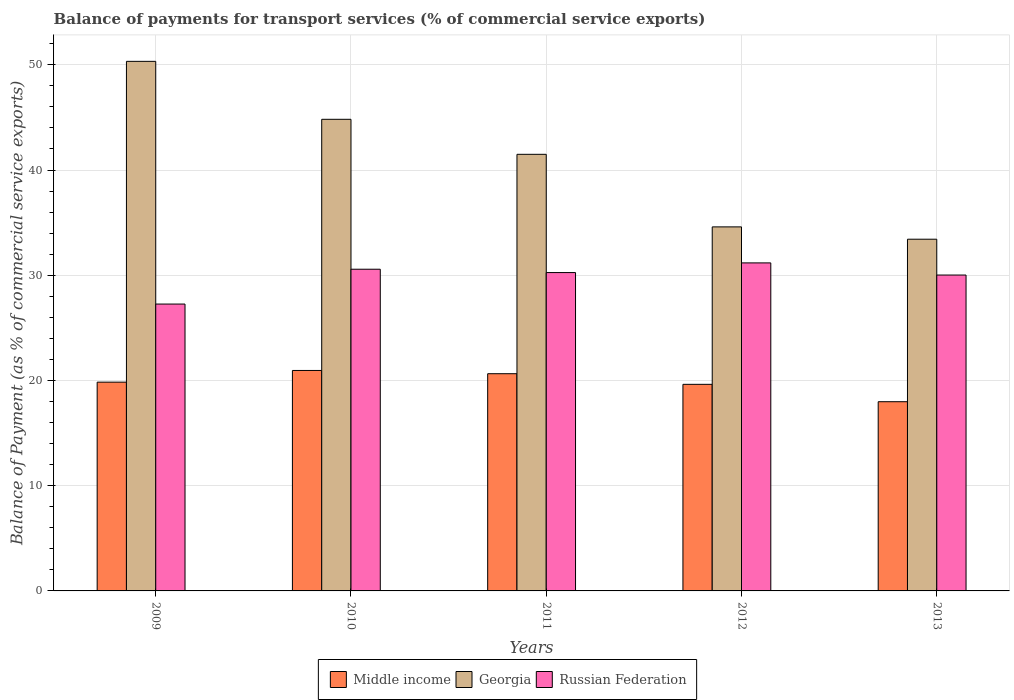How many different coloured bars are there?
Provide a short and direct response. 3. Are the number of bars per tick equal to the number of legend labels?
Ensure brevity in your answer.  Yes. Are the number of bars on each tick of the X-axis equal?
Your answer should be very brief. Yes. How many bars are there on the 1st tick from the left?
Your response must be concise. 3. How many bars are there on the 1st tick from the right?
Keep it short and to the point. 3. What is the balance of payments for transport services in Russian Federation in 2011?
Keep it short and to the point. 30.25. Across all years, what is the maximum balance of payments for transport services in Middle income?
Your response must be concise. 20.95. Across all years, what is the minimum balance of payments for transport services in Georgia?
Your response must be concise. 33.42. What is the total balance of payments for transport services in Russian Federation in the graph?
Keep it short and to the point. 149.28. What is the difference between the balance of payments for transport services in Georgia in 2009 and that in 2010?
Provide a succinct answer. 5.51. What is the difference between the balance of payments for transport services in Georgia in 2011 and the balance of payments for transport services in Russian Federation in 2009?
Ensure brevity in your answer.  14.23. What is the average balance of payments for transport services in Middle income per year?
Offer a very short reply. 19.81. In the year 2013, what is the difference between the balance of payments for transport services in Middle income and balance of payments for transport services in Georgia?
Offer a terse response. -15.44. In how many years, is the balance of payments for transport services in Georgia greater than 26 %?
Offer a very short reply. 5. What is the ratio of the balance of payments for transport services in Russian Federation in 2010 to that in 2013?
Provide a short and direct response. 1.02. Is the balance of payments for transport services in Georgia in 2009 less than that in 2010?
Give a very brief answer. No. Is the difference between the balance of payments for transport services in Middle income in 2011 and 2013 greater than the difference between the balance of payments for transport services in Georgia in 2011 and 2013?
Your answer should be very brief. No. What is the difference between the highest and the second highest balance of payments for transport services in Georgia?
Your answer should be very brief. 5.51. What is the difference between the highest and the lowest balance of payments for transport services in Georgia?
Offer a very short reply. 16.9. What does the 3rd bar from the left in 2011 represents?
Your response must be concise. Russian Federation. What does the 1st bar from the right in 2012 represents?
Make the answer very short. Russian Federation. Are all the bars in the graph horizontal?
Offer a terse response. No. How many years are there in the graph?
Ensure brevity in your answer.  5. Does the graph contain any zero values?
Give a very brief answer. No. Does the graph contain grids?
Give a very brief answer. Yes. Where does the legend appear in the graph?
Provide a short and direct response. Bottom center. How are the legend labels stacked?
Your response must be concise. Horizontal. What is the title of the graph?
Offer a very short reply. Balance of payments for transport services (% of commercial service exports). Does "Somalia" appear as one of the legend labels in the graph?
Your answer should be compact. No. What is the label or title of the X-axis?
Your answer should be compact. Years. What is the label or title of the Y-axis?
Offer a terse response. Balance of Payment (as % of commercial service exports). What is the Balance of Payment (as % of commercial service exports) of Middle income in 2009?
Your answer should be compact. 19.84. What is the Balance of Payment (as % of commercial service exports) of Georgia in 2009?
Offer a very short reply. 50.33. What is the Balance of Payment (as % of commercial service exports) of Russian Federation in 2009?
Offer a terse response. 27.26. What is the Balance of Payment (as % of commercial service exports) in Middle income in 2010?
Keep it short and to the point. 20.95. What is the Balance of Payment (as % of commercial service exports) of Georgia in 2010?
Make the answer very short. 44.82. What is the Balance of Payment (as % of commercial service exports) of Russian Federation in 2010?
Offer a very short reply. 30.57. What is the Balance of Payment (as % of commercial service exports) in Middle income in 2011?
Keep it short and to the point. 20.64. What is the Balance of Payment (as % of commercial service exports) of Georgia in 2011?
Your answer should be compact. 41.49. What is the Balance of Payment (as % of commercial service exports) of Russian Federation in 2011?
Ensure brevity in your answer.  30.25. What is the Balance of Payment (as % of commercial service exports) of Middle income in 2012?
Give a very brief answer. 19.63. What is the Balance of Payment (as % of commercial service exports) in Georgia in 2012?
Keep it short and to the point. 34.6. What is the Balance of Payment (as % of commercial service exports) of Russian Federation in 2012?
Your response must be concise. 31.17. What is the Balance of Payment (as % of commercial service exports) in Middle income in 2013?
Provide a short and direct response. 17.98. What is the Balance of Payment (as % of commercial service exports) in Georgia in 2013?
Make the answer very short. 33.42. What is the Balance of Payment (as % of commercial service exports) in Russian Federation in 2013?
Your answer should be very brief. 30.02. Across all years, what is the maximum Balance of Payment (as % of commercial service exports) of Middle income?
Your response must be concise. 20.95. Across all years, what is the maximum Balance of Payment (as % of commercial service exports) of Georgia?
Provide a succinct answer. 50.33. Across all years, what is the maximum Balance of Payment (as % of commercial service exports) in Russian Federation?
Keep it short and to the point. 31.17. Across all years, what is the minimum Balance of Payment (as % of commercial service exports) in Middle income?
Keep it short and to the point. 17.98. Across all years, what is the minimum Balance of Payment (as % of commercial service exports) in Georgia?
Provide a short and direct response. 33.42. Across all years, what is the minimum Balance of Payment (as % of commercial service exports) of Russian Federation?
Your answer should be compact. 27.26. What is the total Balance of Payment (as % of commercial service exports) of Middle income in the graph?
Ensure brevity in your answer.  99.05. What is the total Balance of Payment (as % of commercial service exports) in Georgia in the graph?
Your answer should be very brief. 204.66. What is the total Balance of Payment (as % of commercial service exports) in Russian Federation in the graph?
Ensure brevity in your answer.  149.28. What is the difference between the Balance of Payment (as % of commercial service exports) of Middle income in 2009 and that in 2010?
Provide a short and direct response. -1.11. What is the difference between the Balance of Payment (as % of commercial service exports) in Georgia in 2009 and that in 2010?
Keep it short and to the point. 5.51. What is the difference between the Balance of Payment (as % of commercial service exports) of Russian Federation in 2009 and that in 2010?
Ensure brevity in your answer.  -3.31. What is the difference between the Balance of Payment (as % of commercial service exports) of Middle income in 2009 and that in 2011?
Offer a terse response. -0.8. What is the difference between the Balance of Payment (as % of commercial service exports) of Georgia in 2009 and that in 2011?
Your answer should be compact. 8.84. What is the difference between the Balance of Payment (as % of commercial service exports) in Russian Federation in 2009 and that in 2011?
Offer a very short reply. -2.99. What is the difference between the Balance of Payment (as % of commercial service exports) in Middle income in 2009 and that in 2012?
Provide a short and direct response. 0.21. What is the difference between the Balance of Payment (as % of commercial service exports) of Georgia in 2009 and that in 2012?
Provide a succinct answer. 15.73. What is the difference between the Balance of Payment (as % of commercial service exports) of Russian Federation in 2009 and that in 2012?
Make the answer very short. -3.91. What is the difference between the Balance of Payment (as % of commercial service exports) in Middle income in 2009 and that in 2013?
Your response must be concise. 1.86. What is the difference between the Balance of Payment (as % of commercial service exports) in Georgia in 2009 and that in 2013?
Your answer should be compact. 16.9. What is the difference between the Balance of Payment (as % of commercial service exports) in Russian Federation in 2009 and that in 2013?
Your answer should be compact. -2.76. What is the difference between the Balance of Payment (as % of commercial service exports) in Middle income in 2010 and that in 2011?
Give a very brief answer. 0.31. What is the difference between the Balance of Payment (as % of commercial service exports) in Georgia in 2010 and that in 2011?
Your answer should be compact. 3.33. What is the difference between the Balance of Payment (as % of commercial service exports) of Russian Federation in 2010 and that in 2011?
Make the answer very short. 0.32. What is the difference between the Balance of Payment (as % of commercial service exports) in Middle income in 2010 and that in 2012?
Make the answer very short. 1.32. What is the difference between the Balance of Payment (as % of commercial service exports) in Georgia in 2010 and that in 2012?
Give a very brief answer. 10.22. What is the difference between the Balance of Payment (as % of commercial service exports) in Russian Federation in 2010 and that in 2012?
Your response must be concise. -0.6. What is the difference between the Balance of Payment (as % of commercial service exports) in Middle income in 2010 and that in 2013?
Offer a very short reply. 2.97. What is the difference between the Balance of Payment (as % of commercial service exports) of Georgia in 2010 and that in 2013?
Ensure brevity in your answer.  11.4. What is the difference between the Balance of Payment (as % of commercial service exports) in Russian Federation in 2010 and that in 2013?
Provide a short and direct response. 0.55. What is the difference between the Balance of Payment (as % of commercial service exports) of Middle income in 2011 and that in 2012?
Offer a terse response. 1.01. What is the difference between the Balance of Payment (as % of commercial service exports) in Georgia in 2011 and that in 2012?
Make the answer very short. 6.9. What is the difference between the Balance of Payment (as % of commercial service exports) of Russian Federation in 2011 and that in 2012?
Your response must be concise. -0.92. What is the difference between the Balance of Payment (as % of commercial service exports) in Middle income in 2011 and that in 2013?
Offer a terse response. 2.66. What is the difference between the Balance of Payment (as % of commercial service exports) in Georgia in 2011 and that in 2013?
Your response must be concise. 8.07. What is the difference between the Balance of Payment (as % of commercial service exports) in Russian Federation in 2011 and that in 2013?
Make the answer very short. 0.24. What is the difference between the Balance of Payment (as % of commercial service exports) in Middle income in 2012 and that in 2013?
Offer a very short reply. 1.65. What is the difference between the Balance of Payment (as % of commercial service exports) of Georgia in 2012 and that in 2013?
Provide a succinct answer. 1.17. What is the difference between the Balance of Payment (as % of commercial service exports) of Russian Federation in 2012 and that in 2013?
Keep it short and to the point. 1.15. What is the difference between the Balance of Payment (as % of commercial service exports) in Middle income in 2009 and the Balance of Payment (as % of commercial service exports) in Georgia in 2010?
Your response must be concise. -24.98. What is the difference between the Balance of Payment (as % of commercial service exports) in Middle income in 2009 and the Balance of Payment (as % of commercial service exports) in Russian Federation in 2010?
Ensure brevity in your answer.  -10.73. What is the difference between the Balance of Payment (as % of commercial service exports) of Georgia in 2009 and the Balance of Payment (as % of commercial service exports) of Russian Federation in 2010?
Keep it short and to the point. 19.75. What is the difference between the Balance of Payment (as % of commercial service exports) in Middle income in 2009 and the Balance of Payment (as % of commercial service exports) in Georgia in 2011?
Give a very brief answer. -21.65. What is the difference between the Balance of Payment (as % of commercial service exports) of Middle income in 2009 and the Balance of Payment (as % of commercial service exports) of Russian Federation in 2011?
Ensure brevity in your answer.  -10.41. What is the difference between the Balance of Payment (as % of commercial service exports) of Georgia in 2009 and the Balance of Payment (as % of commercial service exports) of Russian Federation in 2011?
Provide a succinct answer. 20.07. What is the difference between the Balance of Payment (as % of commercial service exports) of Middle income in 2009 and the Balance of Payment (as % of commercial service exports) of Georgia in 2012?
Ensure brevity in your answer.  -14.75. What is the difference between the Balance of Payment (as % of commercial service exports) of Middle income in 2009 and the Balance of Payment (as % of commercial service exports) of Russian Federation in 2012?
Offer a very short reply. -11.33. What is the difference between the Balance of Payment (as % of commercial service exports) in Georgia in 2009 and the Balance of Payment (as % of commercial service exports) in Russian Federation in 2012?
Your response must be concise. 19.15. What is the difference between the Balance of Payment (as % of commercial service exports) in Middle income in 2009 and the Balance of Payment (as % of commercial service exports) in Georgia in 2013?
Offer a very short reply. -13.58. What is the difference between the Balance of Payment (as % of commercial service exports) of Middle income in 2009 and the Balance of Payment (as % of commercial service exports) of Russian Federation in 2013?
Offer a terse response. -10.18. What is the difference between the Balance of Payment (as % of commercial service exports) in Georgia in 2009 and the Balance of Payment (as % of commercial service exports) in Russian Federation in 2013?
Offer a very short reply. 20.31. What is the difference between the Balance of Payment (as % of commercial service exports) in Middle income in 2010 and the Balance of Payment (as % of commercial service exports) in Georgia in 2011?
Your answer should be compact. -20.54. What is the difference between the Balance of Payment (as % of commercial service exports) in Middle income in 2010 and the Balance of Payment (as % of commercial service exports) in Russian Federation in 2011?
Your answer should be compact. -9.3. What is the difference between the Balance of Payment (as % of commercial service exports) in Georgia in 2010 and the Balance of Payment (as % of commercial service exports) in Russian Federation in 2011?
Keep it short and to the point. 14.57. What is the difference between the Balance of Payment (as % of commercial service exports) in Middle income in 2010 and the Balance of Payment (as % of commercial service exports) in Georgia in 2012?
Keep it short and to the point. -13.64. What is the difference between the Balance of Payment (as % of commercial service exports) in Middle income in 2010 and the Balance of Payment (as % of commercial service exports) in Russian Federation in 2012?
Your answer should be very brief. -10.22. What is the difference between the Balance of Payment (as % of commercial service exports) of Georgia in 2010 and the Balance of Payment (as % of commercial service exports) of Russian Federation in 2012?
Provide a succinct answer. 13.65. What is the difference between the Balance of Payment (as % of commercial service exports) of Middle income in 2010 and the Balance of Payment (as % of commercial service exports) of Georgia in 2013?
Provide a succinct answer. -12.47. What is the difference between the Balance of Payment (as % of commercial service exports) in Middle income in 2010 and the Balance of Payment (as % of commercial service exports) in Russian Federation in 2013?
Your answer should be compact. -9.07. What is the difference between the Balance of Payment (as % of commercial service exports) of Georgia in 2010 and the Balance of Payment (as % of commercial service exports) of Russian Federation in 2013?
Offer a very short reply. 14.8. What is the difference between the Balance of Payment (as % of commercial service exports) in Middle income in 2011 and the Balance of Payment (as % of commercial service exports) in Georgia in 2012?
Offer a very short reply. -13.95. What is the difference between the Balance of Payment (as % of commercial service exports) of Middle income in 2011 and the Balance of Payment (as % of commercial service exports) of Russian Federation in 2012?
Your answer should be compact. -10.53. What is the difference between the Balance of Payment (as % of commercial service exports) in Georgia in 2011 and the Balance of Payment (as % of commercial service exports) in Russian Federation in 2012?
Give a very brief answer. 10.32. What is the difference between the Balance of Payment (as % of commercial service exports) in Middle income in 2011 and the Balance of Payment (as % of commercial service exports) in Georgia in 2013?
Provide a short and direct response. -12.78. What is the difference between the Balance of Payment (as % of commercial service exports) of Middle income in 2011 and the Balance of Payment (as % of commercial service exports) of Russian Federation in 2013?
Provide a succinct answer. -9.38. What is the difference between the Balance of Payment (as % of commercial service exports) in Georgia in 2011 and the Balance of Payment (as % of commercial service exports) in Russian Federation in 2013?
Ensure brevity in your answer.  11.47. What is the difference between the Balance of Payment (as % of commercial service exports) of Middle income in 2012 and the Balance of Payment (as % of commercial service exports) of Georgia in 2013?
Offer a very short reply. -13.79. What is the difference between the Balance of Payment (as % of commercial service exports) in Middle income in 2012 and the Balance of Payment (as % of commercial service exports) in Russian Federation in 2013?
Offer a very short reply. -10.39. What is the difference between the Balance of Payment (as % of commercial service exports) of Georgia in 2012 and the Balance of Payment (as % of commercial service exports) of Russian Federation in 2013?
Offer a terse response. 4.58. What is the average Balance of Payment (as % of commercial service exports) of Middle income per year?
Provide a short and direct response. 19.81. What is the average Balance of Payment (as % of commercial service exports) in Georgia per year?
Your answer should be compact. 40.93. What is the average Balance of Payment (as % of commercial service exports) in Russian Federation per year?
Offer a terse response. 29.86. In the year 2009, what is the difference between the Balance of Payment (as % of commercial service exports) in Middle income and Balance of Payment (as % of commercial service exports) in Georgia?
Ensure brevity in your answer.  -30.49. In the year 2009, what is the difference between the Balance of Payment (as % of commercial service exports) of Middle income and Balance of Payment (as % of commercial service exports) of Russian Federation?
Make the answer very short. -7.42. In the year 2009, what is the difference between the Balance of Payment (as % of commercial service exports) in Georgia and Balance of Payment (as % of commercial service exports) in Russian Federation?
Provide a succinct answer. 23.07. In the year 2010, what is the difference between the Balance of Payment (as % of commercial service exports) in Middle income and Balance of Payment (as % of commercial service exports) in Georgia?
Provide a short and direct response. -23.87. In the year 2010, what is the difference between the Balance of Payment (as % of commercial service exports) in Middle income and Balance of Payment (as % of commercial service exports) in Russian Federation?
Provide a succinct answer. -9.62. In the year 2010, what is the difference between the Balance of Payment (as % of commercial service exports) in Georgia and Balance of Payment (as % of commercial service exports) in Russian Federation?
Offer a terse response. 14.25. In the year 2011, what is the difference between the Balance of Payment (as % of commercial service exports) of Middle income and Balance of Payment (as % of commercial service exports) of Georgia?
Keep it short and to the point. -20.85. In the year 2011, what is the difference between the Balance of Payment (as % of commercial service exports) of Middle income and Balance of Payment (as % of commercial service exports) of Russian Federation?
Provide a succinct answer. -9.61. In the year 2011, what is the difference between the Balance of Payment (as % of commercial service exports) of Georgia and Balance of Payment (as % of commercial service exports) of Russian Federation?
Offer a very short reply. 11.24. In the year 2012, what is the difference between the Balance of Payment (as % of commercial service exports) in Middle income and Balance of Payment (as % of commercial service exports) in Georgia?
Your answer should be very brief. -14.96. In the year 2012, what is the difference between the Balance of Payment (as % of commercial service exports) of Middle income and Balance of Payment (as % of commercial service exports) of Russian Federation?
Your answer should be compact. -11.54. In the year 2012, what is the difference between the Balance of Payment (as % of commercial service exports) in Georgia and Balance of Payment (as % of commercial service exports) in Russian Federation?
Offer a very short reply. 3.42. In the year 2013, what is the difference between the Balance of Payment (as % of commercial service exports) in Middle income and Balance of Payment (as % of commercial service exports) in Georgia?
Provide a succinct answer. -15.44. In the year 2013, what is the difference between the Balance of Payment (as % of commercial service exports) of Middle income and Balance of Payment (as % of commercial service exports) of Russian Federation?
Your answer should be compact. -12.04. In the year 2013, what is the difference between the Balance of Payment (as % of commercial service exports) in Georgia and Balance of Payment (as % of commercial service exports) in Russian Federation?
Make the answer very short. 3.4. What is the ratio of the Balance of Payment (as % of commercial service exports) in Middle income in 2009 to that in 2010?
Make the answer very short. 0.95. What is the ratio of the Balance of Payment (as % of commercial service exports) in Georgia in 2009 to that in 2010?
Your response must be concise. 1.12. What is the ratio of the Balance of Payment (as % of commercial service exports) in Russian Federation in 2009 to that in 2010?
Your response must be concise. 0.89. What is the ratio of the Balance of Payment (as % of commercial service exports) in Middle income in 2009 to that in 2011?
Ensure brevity in your answer.  0.96. What is the ratio of the Balance of Payment (as % of commercial service exports) of Georgia in 2009 to that in 2011?
Provide a short and direct response. 1.21. What is the ratio of the Balance of Payment (as % of commercial service exports) in Russian Federation in 2009 to that in 2011?
Your answer should be compact. 0.9. What is the ratio of the Balance of Payment (as % of commercial service exports) of Middle income in 2009 to that in 2012?
Provide a short and direct response. 1.01. What is the ratio of the Balance of Payment (as % of commercial service exports) in Georgia in 2009 to that in 2012?
Make the answer very short. 1.45. What is the ratio of the Balance of Payment (as % of commercial service exports) in Russian Federation in 2009 to that in 2012?
Provide a succinct answer. 0.87. What is the ratio of the Balance of Payment (as % of commercial service exports) in Middle income in 2009 to that in 2013?
Your answer should be compact. 1.1. What is the ratio of the Balance of Payment (as % of commercial service exports) of Georgia in 2009 to that in 2013?
Keep it short and to the point. 1.51. What is the ratio of the Balance of Payment (as % of commercial service exports) of Russian Federation in 2009 to that in 2013?
Give a very brief answer. 0.91. What is the ratio of the Balance of Payment (as % of commercial service exports) in Middle income in 2010 to that in 2011?
Your answer should be very brief. 1.01. What is the ratio of the Balance of Payment (as % of commercial service exports) of Georgia in 2010 to that in 2011?
Give a very brief answer. 1.08. What is the ratio of the Balance of Payment (as % of commercial service exports) in Russian Federation in 2010 to that in 2011?
Offer a very short reply. 1.01. What is the ratio of the Balance of Payment (as % of commercial service exports) in Middle income in 2010 to that in 2012?
Provide a short and direct response. 1.07. What is the ratio of the Balance of Payment (as % of commercial service exports) of Georgia in 2010 to that in 2012?
Your response must be concise. 1.3. What is the ratio of the Balance of Payment (as % of commercial service exports) in Russian Federation in 2010 to that in 2012?
Provide a succinct answer. 0.98. What is the ratio of the Balance of Payment (as % of commercial service exports) of Middle income in 2010 to that in 2013?
Provide a short and direct response. 1.17. What is the ratio of the Balance of Payment (as % of commercial service exports) of Georgia in 2010 to that in 2013?
Keep it short and to the point. 1.34. What is the ratio of the Balance of Payment (as % of commercial service exports) in Russian Federation in 2010 to that in 2013?
Your answer should be very brief. 1.02. What is the ratio of the Balance of Payment (as % of commercial service exports) in Middle income in 2011 to that in 2012?
Give a very brief answer. 1.05. What is the ratio of the Balance of Payment (as % of commercial service exports) in Georgia in 2011 to that in 2012?
Provide a succinct answer. 1.2. What is the ratio of the Balance of Payment (as % of commercial service exports) in Russian Federation in 2011 to that in 2012?
Your answer should be compact. 0.97. What is the ratio of the Balance of Payment (as % of commercial service exports) of Middle income in 2011 to that in 2013?
Ensure brevity in your answer.  1.15. What is the ratio of the Balance of Payment (as % of commercial service exports) in Georgia in 2011 to that in 2013?
Offer a terse response. 1.24. What is the ratio of the Balance of Payment (as % of commercial service exports) in Middle income in 2012 to that in 2013?
Give a very brief answer. 1.09. What is the ratio of the Balance of Payment (as % of commercial service exports) in Georgia in 2012 to that in 2013?
Make the answer very short. 1.04. What is the ratio of the Balance of Payment (as % of commercial service exports) of Russian Federation in 2012 to that in 2013?
Your answer should be compact. 1.04. What is the difference between the highest and the second highest Balance of Payment (as % of commercial service exports) in Middle income?
Offer a very short reply. 0.31. What is the difference between the highest and the second highest Balance of Payment (as % of commercial service exports) of Georgia?
Make the answer very short. 5.51. What is the difference between the highest and the second highest Balance of Payment (as % of commercial service exports) of Russian Federation?
Provide a short and direct response. 0.6. What is the difference between the highest and the lowest Balance of Payment (as % of commercial service exports) in Middle income?
Your response must be concise. 2.97. What is the difference between the highest and the lowest Balance of Payment (as % of commercial service exports) of Georgia?
Offer a terse response. 16.9. What is the difference between the highest and the lowest Balance of Payment (as % of commercial service exports) in Russian Federation?
Ensure brevity in your answer.  3.91. 